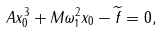<formula> <loc_0><loc_0><loc_500><loc_500>A x _ { 0 } ^ { 3 } + M \omega _ { 1 } ^ { 2 } x _ { 0 } - \widetilde { f } = 0 ,</formula> 